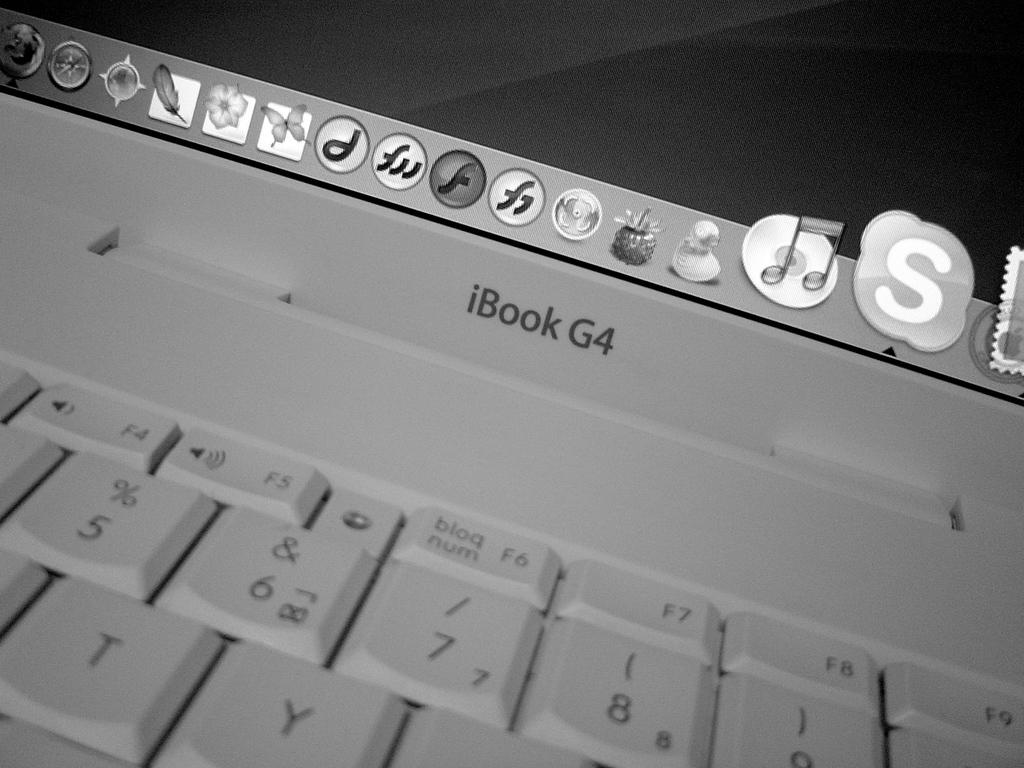<image>
Relay a brief, clear account of the picture shown. A close up of the keyboard of an iBook G4. 